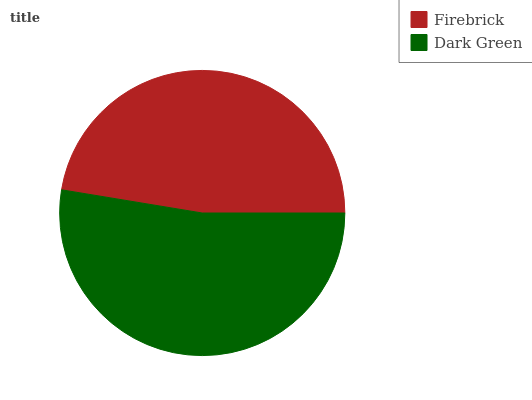Is Firebrick the minimum?
Answer yes or no. Yes. Is Dark Green the maximum?
Answer yes or no. Yes. Is Dark Green the minimum?
Answer yes or no. No. Is Dark Green greater than Firebrick?
Answer yes or no. Yes. Is Firebrick less than Dark Green?
Answer yes or no. Yes. Is Firebrick greater than Dark Green?
Answer yes or no. No. Is Dark Green less than Firebrick?
Answer yes or no. No. Is Dark Green the high median?
Answer yes or no. Yes. Is Firebrick the low median?
Answer yes or no. Yes. Is Firebrick the high median?
Answer yes or no. No. Is Dark Green the low median?
Answer yes or no. No. 